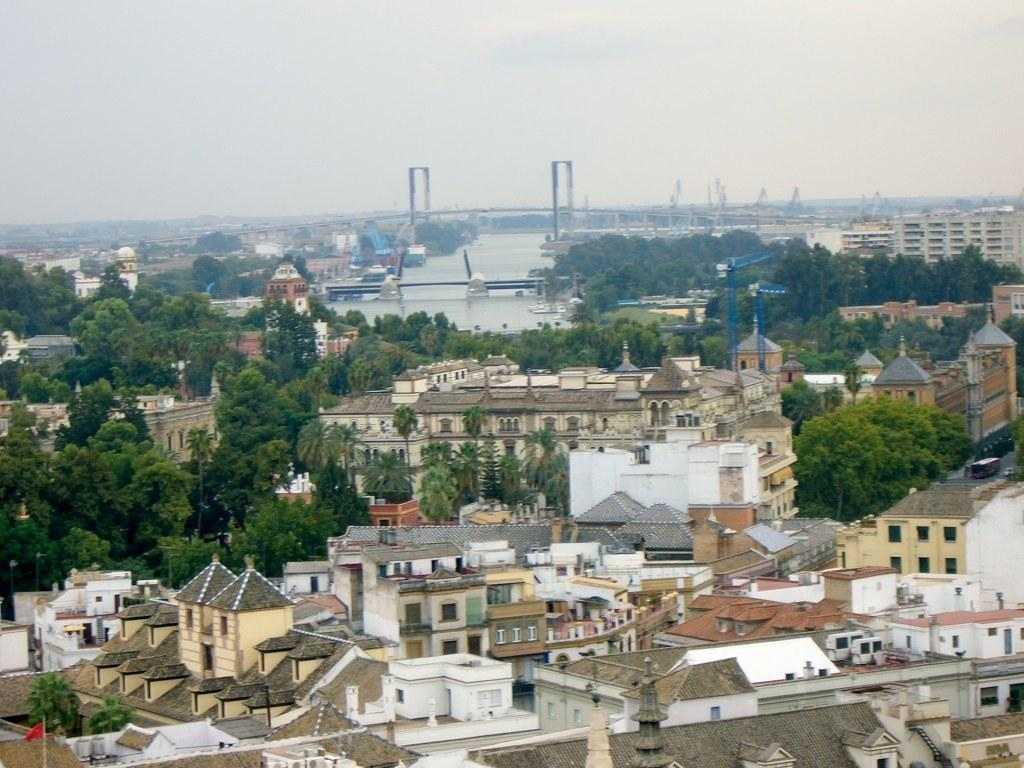What type of structures can be seen in the image? There are houses and buildings in the image. What other natural elements are present in the image? There are trees in the image. What can be seen in the background of the image? There is a water surface and a bridge across the water surface visible in the background of the image. What type of crack is visible on the bridge in the image? There is no crack visible on the bridge in the image. How many clocks can be seen hanging on the buildings in the image? There are no clocks visible on the buildings in the image. 